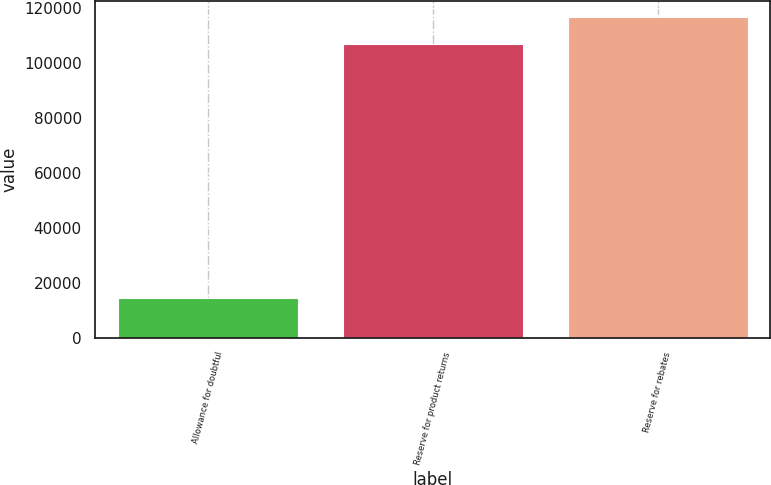Convert chart to OTSL. <chart><loc_0><loc_0><loc_500><loc_500><bar_chart><fcel>Allowance for doubtful<fcel>Reserve for product returns<fcel>Reserve for rebates<nl><fcel>14595<fcel>106864<fcel>116822<nl></chart> 